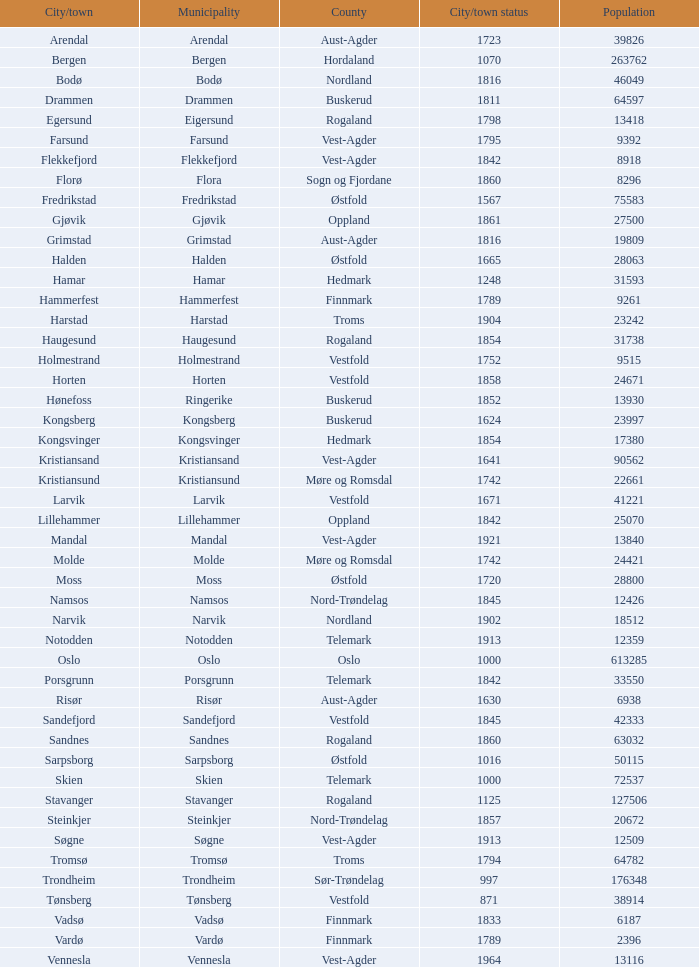Which municipalities located in the county of Finnmark have populations bigger than 6187.0? Hammerfest. 